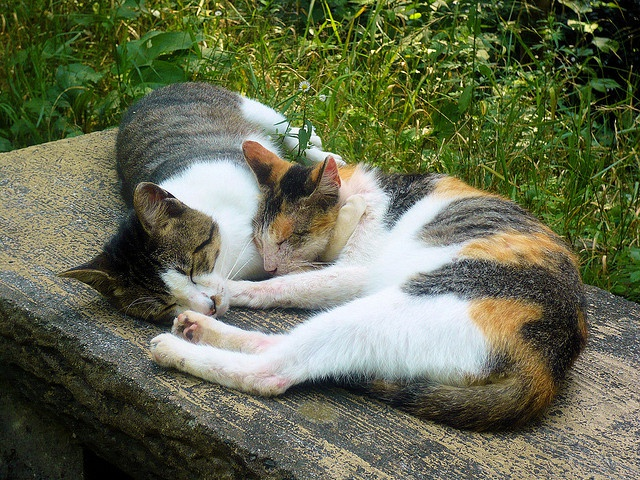Describe the objects in this image and their specific colors. I can see bench in darkgreen, black, gray, tan, and darkgray tones, cat in darkgreen, lightgray, black, gray, and darkgray tones, and cat in darkgreen, black, lightgray, gray, and darkgray tones in this image. 